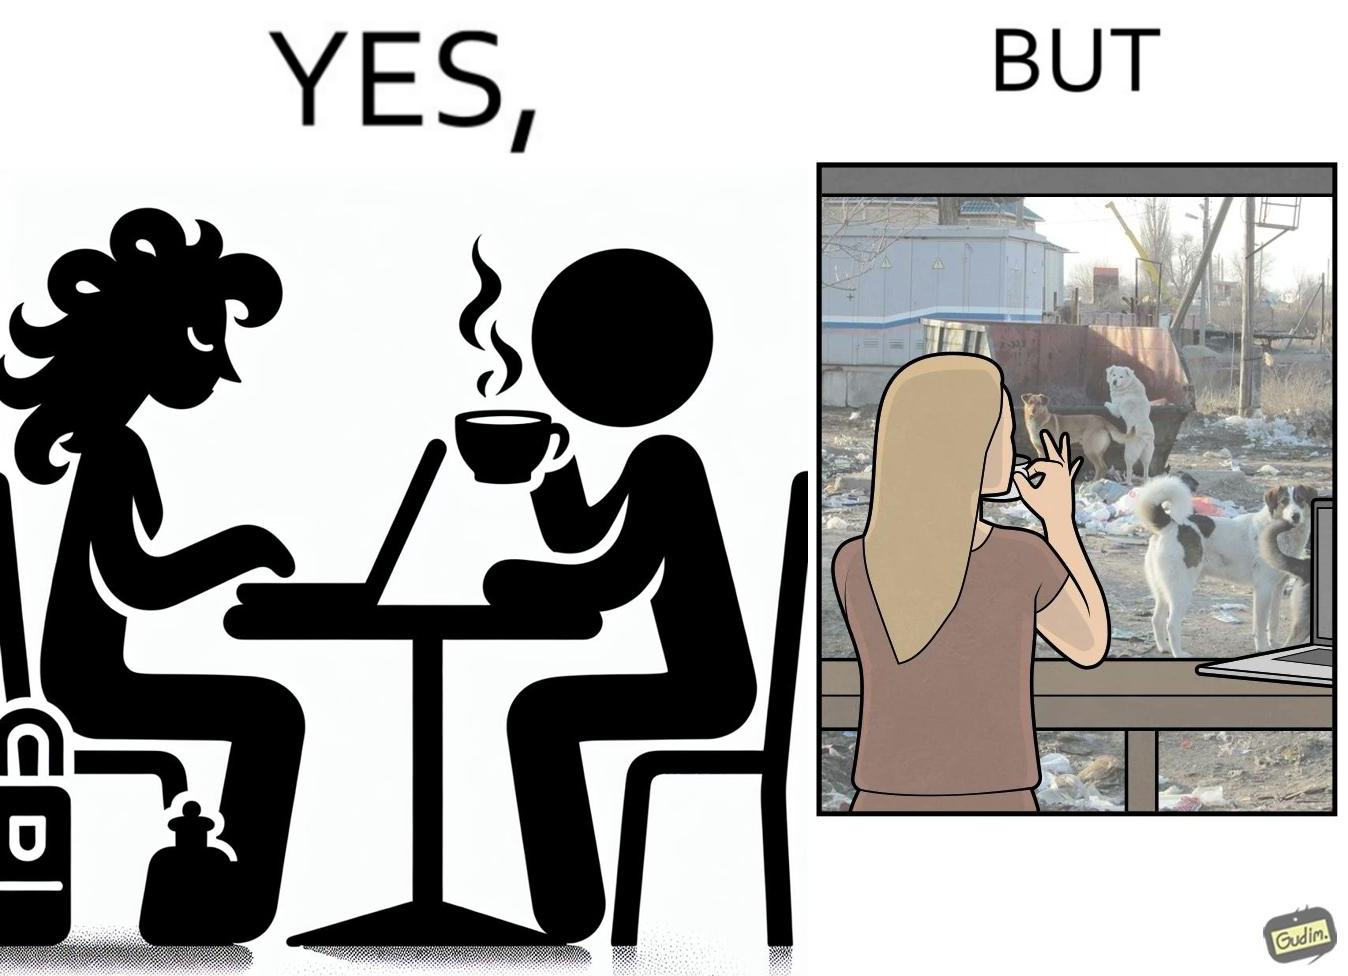What do you see in each half of this image? In the left part of the image: a woman having a cup of some hot beverage at some cafe with probably doing some work in the laptop In the right part of the image: a woman looking outside the window at the stray animals, who are probably in search of some food near the garbage bin 